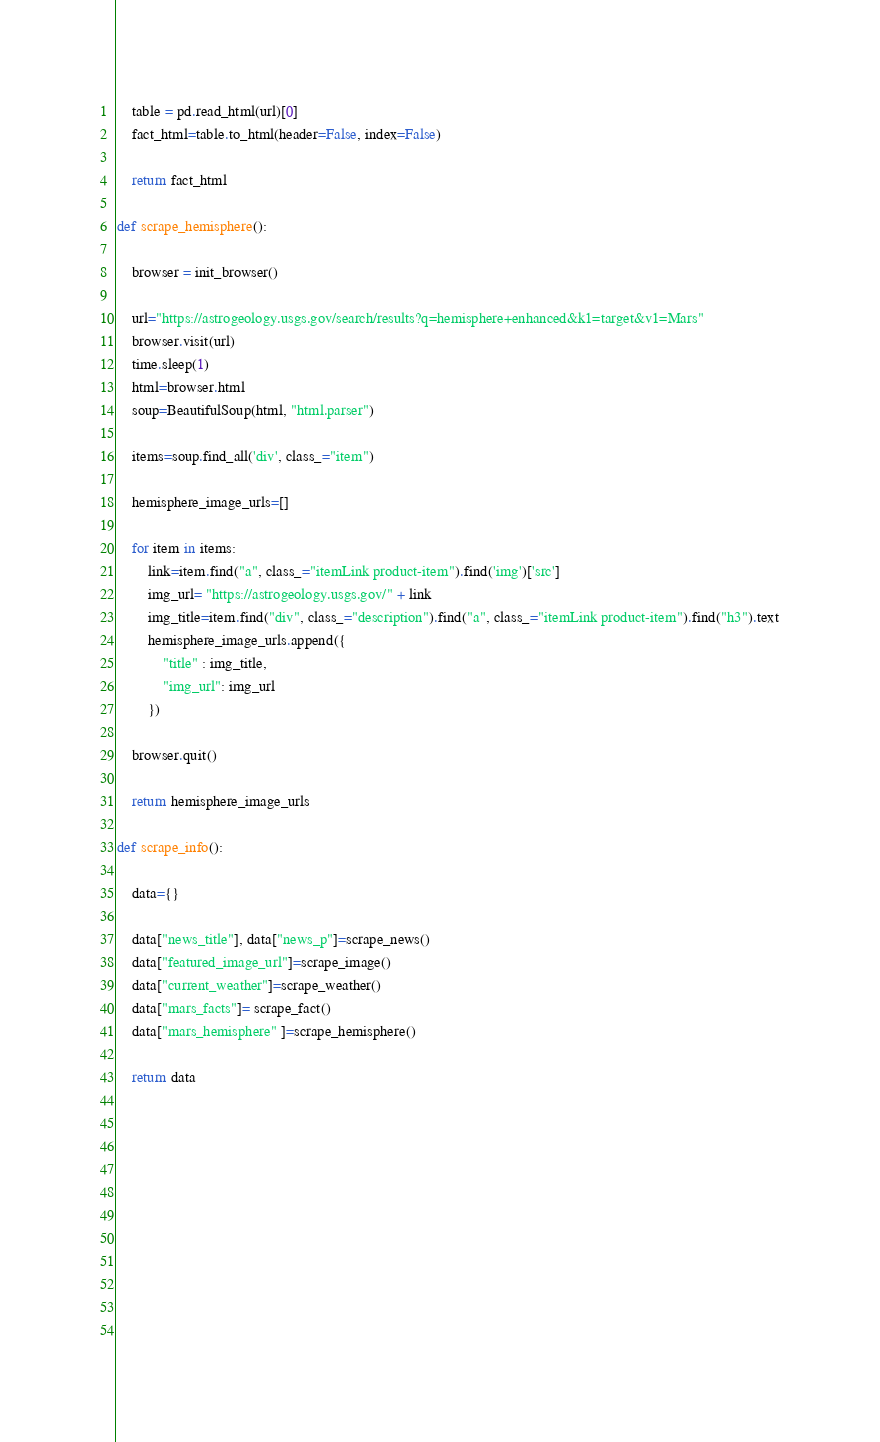<code> <loc_0><loc_0><loc_500><loc_500><_Python_>    table = pd.read_html(url)[0]
    fact_html=table.to_html(header=False, index=False)   

    return fact_html
    
def scrape_hemisphere():

    browser = init_browser()

    url="https://astrogeology.usgs.gov/search/results?q=hemisphere+enhanced&k1=target&v1=Mars"
    browser.visit(url)
    time.sleep(1)
    html=browser.html
    soup=BeautifulSoup(html, "html.parser")

    items=soup.find_all('div', class_="item")

    hemisphere_image_urls=[]

    for item in items:
        link=item.find("a", class_="itemLink product-item").find('img')['src']
        img_url= "https://astrogeology.usgs.gov/" + link
        img_title=item.find("div", class_="description").find("a", class_="itemLink product-item").find("h3").text
        hemisphere_image_urls.append({
            "title" : img_title,
            "img_url": img_url
        })
    
    browser.quit()

    return hemisphere_image_urls

def scrape_info():

    data={}
    
    data["news_title"], data["news_p"]=scrape_news()
    data["featured_image_url"]=scrape_image()
    data["current_weather"]=scrape_weather()
    data["mars_facts"]= scrape_fact()
    data["mars_hemisphere" ]=scrape_hemisphere()   

    return data
       
   







        
  


</code> 